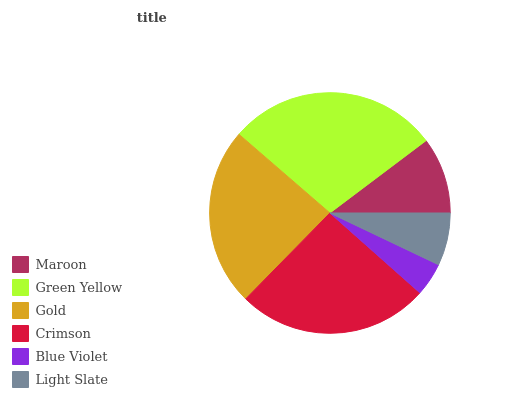Is Blue Violet the minimum?
Answer yes or no. Yes. Is Green Yellow the maximum?
Answer yes or no. Yes. Is Gold the minimum?
Answer yes or no. No. Is Gold the maximum?
Answer yes or no. No. Is Green Yellow greater than Gold?
Answer yes or no. Yes. Is Gold less than Green Yellow?
Answer yes or no. Yes. Is Gold greater than Green Yellow?
Answer yes or no. No. Is Green Yellow less than Gold?
Answer yes or no. No. Is Gold the high median?
Answer yes or no. Yes. Is Maroon the low median?
Answer yes or no. Yes. Is Blue Violet the high median?
Answer yes or no. No. Is Green Yellow the low median?
Answer yes or no. No. 